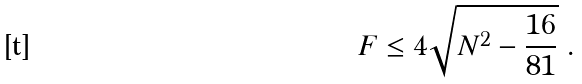<formula> <loc_0><loc_0><loc_500><loc_500>F \leq 4 \sqrt { N ^ { 2 } - \frac { 1 6 } { 8 1 } } \ .</formula> 